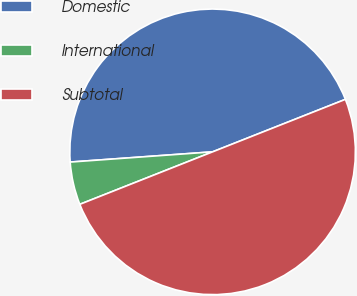Convert chart. <chart><loc_0><loc_0><loc_500><loc_500><pie_chart><fcel>Domestic<fcel>International<fcel>Subtotal<nl><fcel>45.15%<fcel>4.85%<fcel>50.0%<nl></chart> 